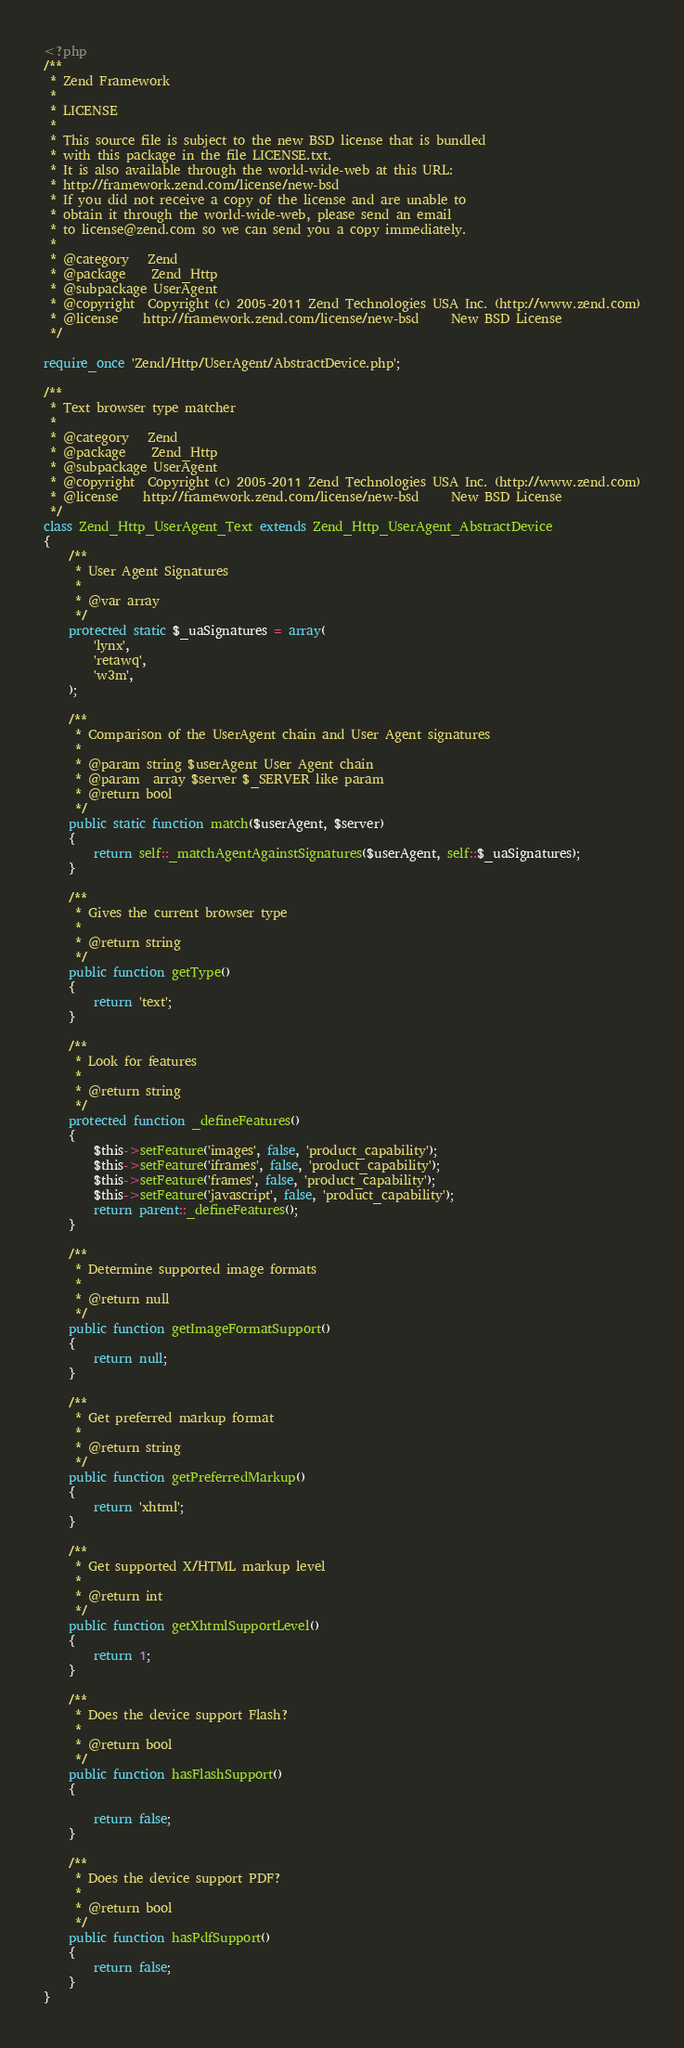Convert code to text. <code><loc_0><loc_0><loc_500><loc_500><_PHP_><?php
/**
 * Zend Framework
 *
 * LICENSE
 *
 * This source file is subject to the new BSD license that is bundled
 * with this package in the file LICENSE.txt.
 * It is also available through the world-wide-web at this URL:
 * http://framework.zend.com/license/new-bsd
 * If you did not receive a copy of the license and are unable to
 * obtain it through the world-wide-web, please send an email
 * to license@zend.com so we can send you a copy immediately.
 *
 * @category   Zend
 * @package    Zend_Http
 * @subpackage UserAgent
 * @copyright  Copyright (c) 2005-2011 Zend Technologies USA Inc. (http://www.zend.com)
 * @license    http://framework.zend.com/license/new-bsd     New BSD License
 */

require_once 'Zend/Http/UserAgent/AbstractDevice.php';

/**
 * Text browser type matcher
 *
 * @category   Zend
 * @package    Zend_Http
 * @subpackage UserAgent
 * @copyright  Copyright (c) 2005-2011 Zend Technologies USA Inc. (http://www.zend.com)
 * @license    http://framework.zend.com/license/new-bsd     New BSD License
 */
class Zend_Http_UserAgent_Text extends Zend_Http_UserAgent_AbstractDevice
{
    /**
     * User Agent Signatures
     *
     * @var array
     */
    protected static $_uaSignatures = array(
        'lynx',
        'retawq',
        'w3m',
    );

    /**
     * Comparison of the UserAgent chain and User Agent signatures
     *
     * @param string $userAgent User Agent chain
     * @param  array $server $_SERVER like param
     * @return bool
     */
    public static function match($userAgent, $server)
    {
        return self::_matchAgentAgainstSignatures($userAgent, self::$_uaSignatures);
    }

    /**
     * Gives the current browser type
     *
     * @return string
     */
    public function getType()
    {
        return 'text';
    }

    /**
     * Look for features
     *
     * @return string
     */
    protected function _defineFeatures()
    {
        $this->setFeature('images', false, 'product_capability');
        $this->setFeature('iframes', false, 'product_capability');
        $this->setFeature('frames', false, 'product_capability');
        $this->setFeature('javascript', false, 'product_capability');
        return parent::_defineFeatures();
    }

    /**
     * Determine supported image formats
     *
     * @return null
     */
    public function getImageFormatSupport()
    {
        return null;
    }

    /**
     * Get preferred markup format
     *
     * @return string
     */
    public function getPreferredMarkup()
    {
        return 'xhtml';
    }

    /**
     * Get supported X/HTML markup level
     *
     * @return int
     */
    public function getXhtmlSupportLevel()
    {
        return 1;
    }

    /**
     * Does the device support Flash?
     *
     * @return bool
     */
    public function hasFlashSupport()
    {

        return false;
    }

    /**
     * Does the device support PDF?
     *
     * @return bool
     */
    public function hasPdfSupport()
    {
        return false;
    }
}
</code> 